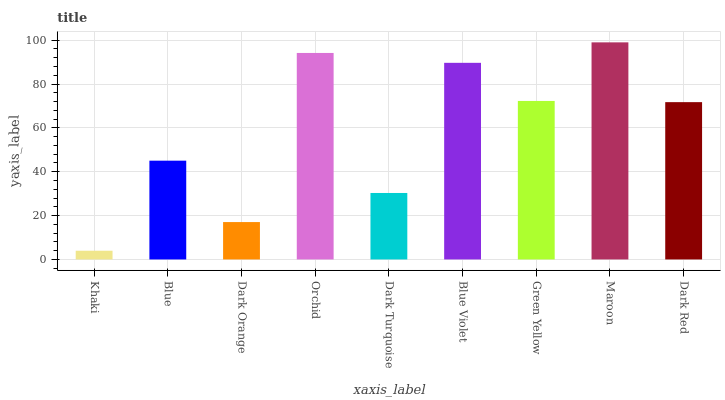Is Khaki the minimum?
Answer yes or no. Yes. Is Maroon the maximum?
Answer yes or no. Yes. Is Blue the minimum?
Answer yes or no. No. Is Blue the maximum?
Answer yes or no. No. Is Blue greater than Khaki?
Answer yes or no. Yes. Is Khaki less than Blue?
Answer yes or no. Yes. Is Khaki greater than Blue?
Answer yes or no. No. Is Blue less than Khaki?
Answer yes or no. No. Is Dark Red the high median?
Answer yes or no. Yes. Is Dark Red the low median?
Answer yes or no. Yes. Is Green Yellow the high median?
Answer yes or no. No. Is Blue the low median?
Answer yes or no. No. 